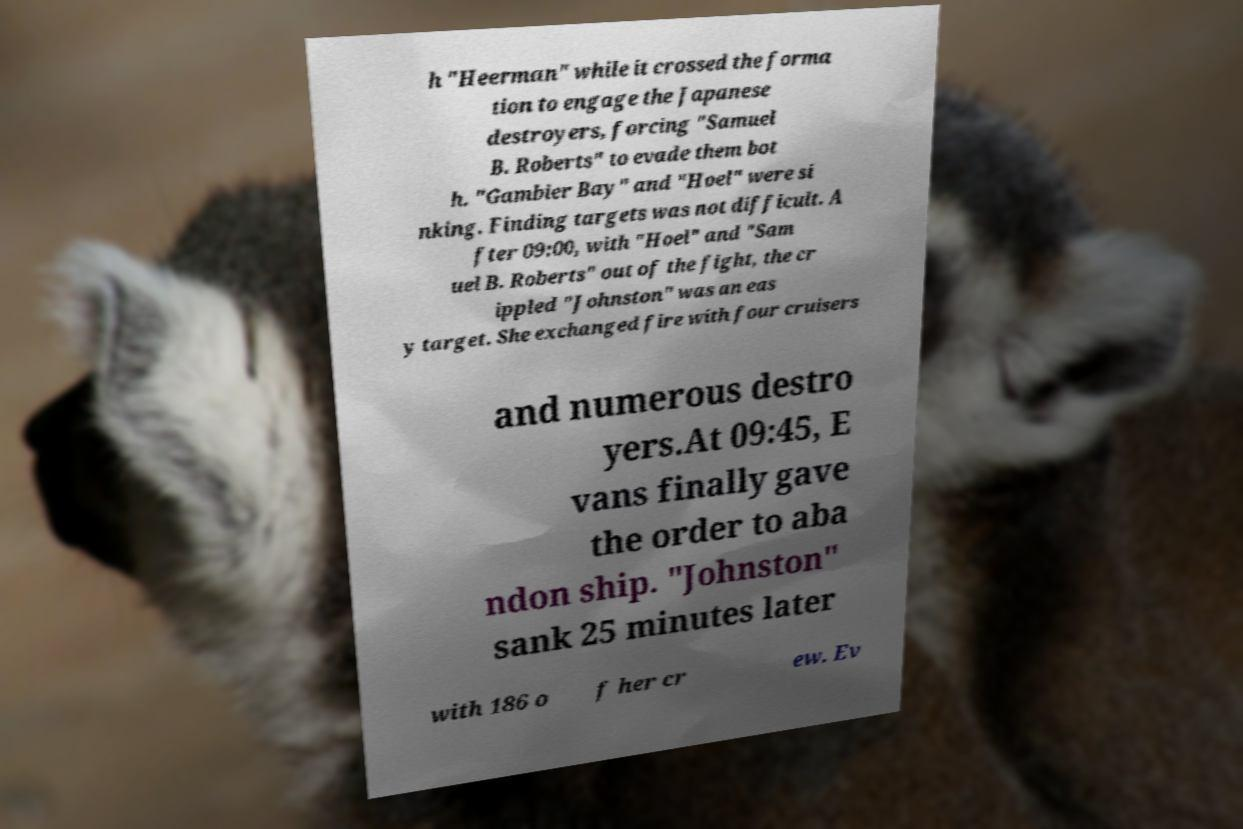Can you accurately transcribe the text from the provided image for me? h "Heerman" while it crossed the forma tion to engage the Japanese destroyers, forcing "Samuel B. Roberts" to evade them bot h. "Gambier Bay" and "Hoel" were si nking. Finding targets was not difficult. A fter 09:00, with "Hoel" and "Sam uel B. Roberts" out of the fight, the cr ippled "Johnston" was an eas y target. She exchanged fire with four cruisers and numerous destro yers.At 09:45, E vans finally gave the order to aba ndon ship. "Johnston" sank 25 minutes later with 186 o f her cr ew. Ev 